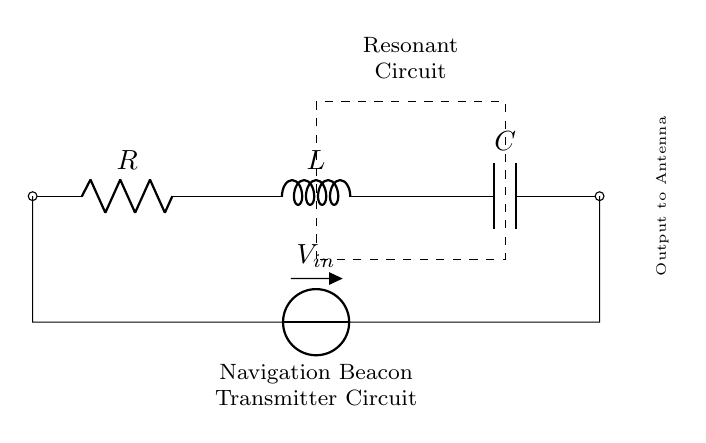What components are present in this circuit? The circuit includes a resistor, an inductor, and a capacitor, which are labeled as R, L, and C respectively.
Answer: Resistor, inductor, capacitor What is the purpose of this circuit? This circuit is labeled as a "Navigation Beacon Transmitter Circuit," indicating its use in navigation technology.
Answer: Navigation beacon transmitter What does the dashed rectangle signify in the circuit? The dashed rectangle denotes the area of the resonant circuit, helping to visualize its boundaries and components at a glance.
Answer: Resonant circuit What is the voltage source of this circuit? The voltage source is labeled as V-in, positioned between two points and supplying energy to the circuit.
Answer: V-in How does the resonant frequency affect the circuit? The resonant frequency is determined by the values of R, L, and C; it affects the circuit's ability to selectively respond to certain frequencies, essential for navigation signaling.
Answer: Affects frequency response What is the function of the output labeled at the right? The output to the antenna indicates that this circuit transmits signals to the antenna, which can then send signals for navigation purposes.
Answer: Transmits signals to antenna 